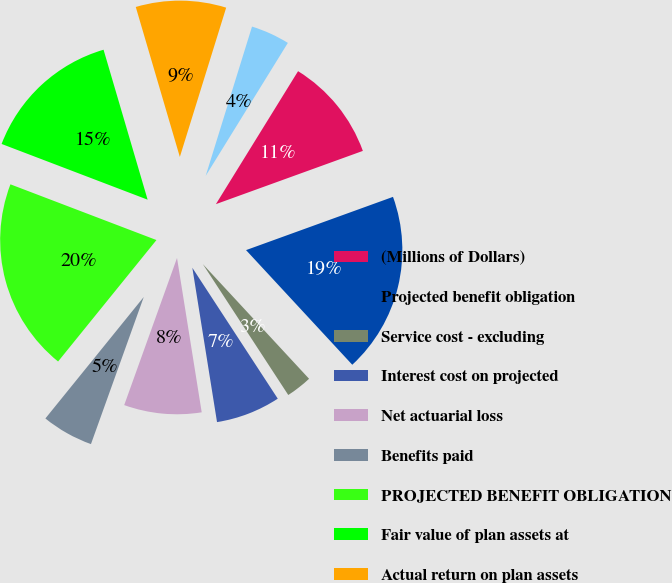Convert chart to OTSL. <chart><loc_0><loc_0><loc_500><loc_500><pie_chart><fcel>(Millions of Dollars)<fcel>Projected benefit obligation<fcel>Service cost - excluding<fcel>Interest cost on projected<fcel>Net actuarial loss<fcel>Benefits paid<fcel>PROJECTED BENEFIT OBLIGATION<fcel>Fair value of plan assets at<fcel>Actual return on plan assets<fcel>Employer contributions<nl><fcel>10.66%<fcel>18.64%<fcel>2.69%<fcel>6.68%<fcel>8.01%<fcel>5.35%<fcel>19.97%<fcel>14.65%<fcel>9.34%<fcel>4.02%<nl></chart> 